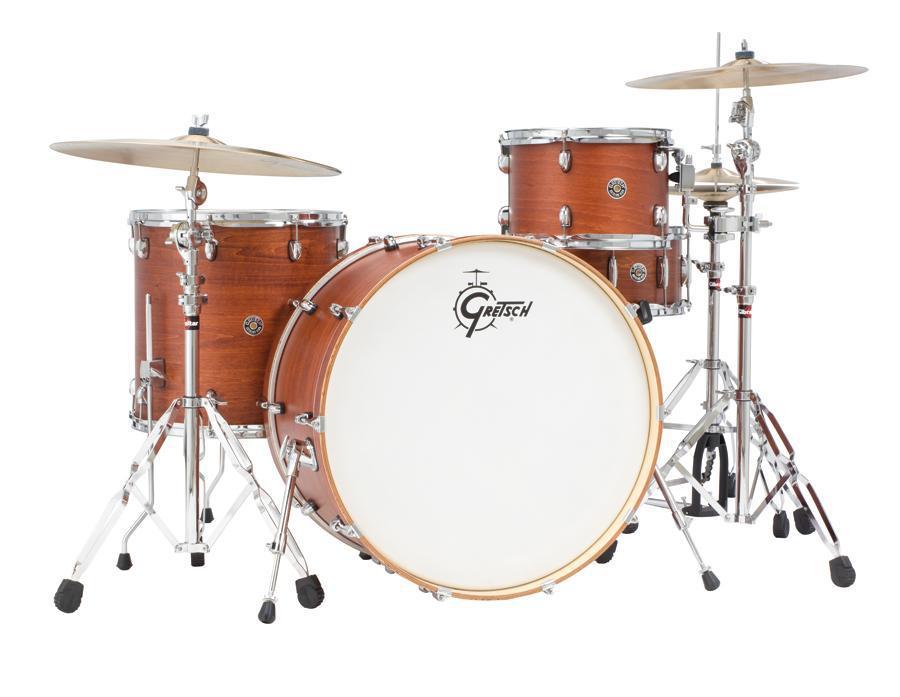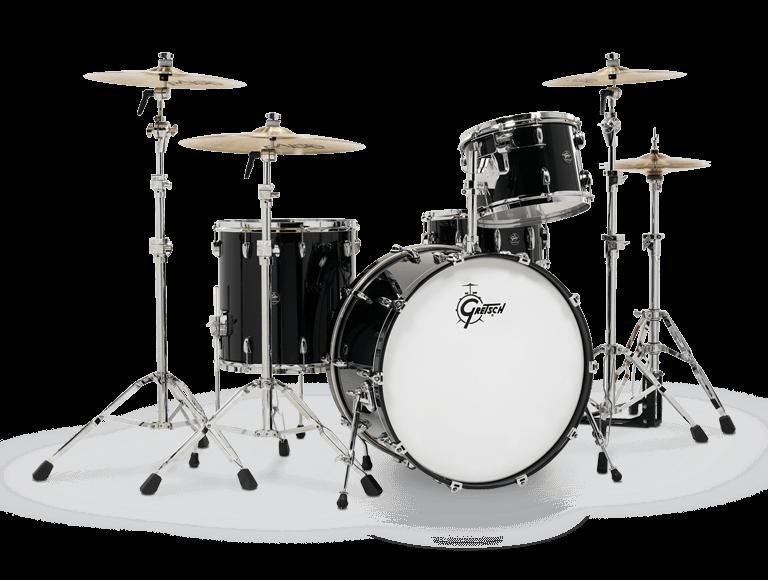The first image is the image on the left, the second image is the image on the right. For the images shown, is this caption "A drum set is placed on a white carpet in front of a black background in one of the pictures." true? Answer yes or no. Yes. 